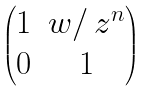<formula> <loc_0><loc_0><loc_500><loc_500>\begin{pmatrix} 1 & w / \, z ^ { n } \\ 0 & 1 \end{pmatrix}</formula> 